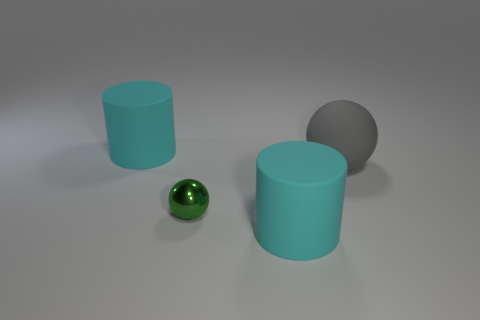Add 1 large rubber objects. How many objects exist? 5 Add 4 large cyan metal cubes. How many large cyan metal cubes exist? 4 Subtract 0 gray cylinders. How many objects are left? 4 Subtract all yellow matte cylinders. Subtract all rubber things. How many objects are left? 1 Add 1 tiny spheres. How many tiny spheres are left? 2 